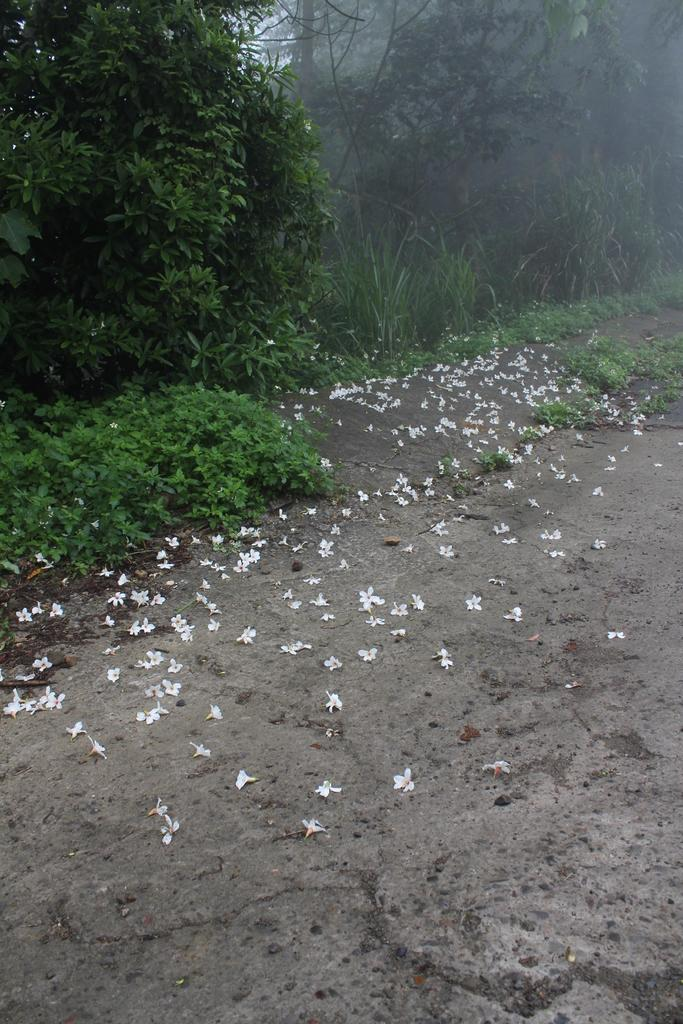What is located on the floor in the foreground area of the image? There are flowers on the floor in the foreground area. What can be seen in the background of the image? There is greenery and the sky visible in the background of the image. How many birds are perched on the coil in the image? There are no birds or coils present in the image. What religious symbols can be seen in the image? There are no religious symbols present in the image. 